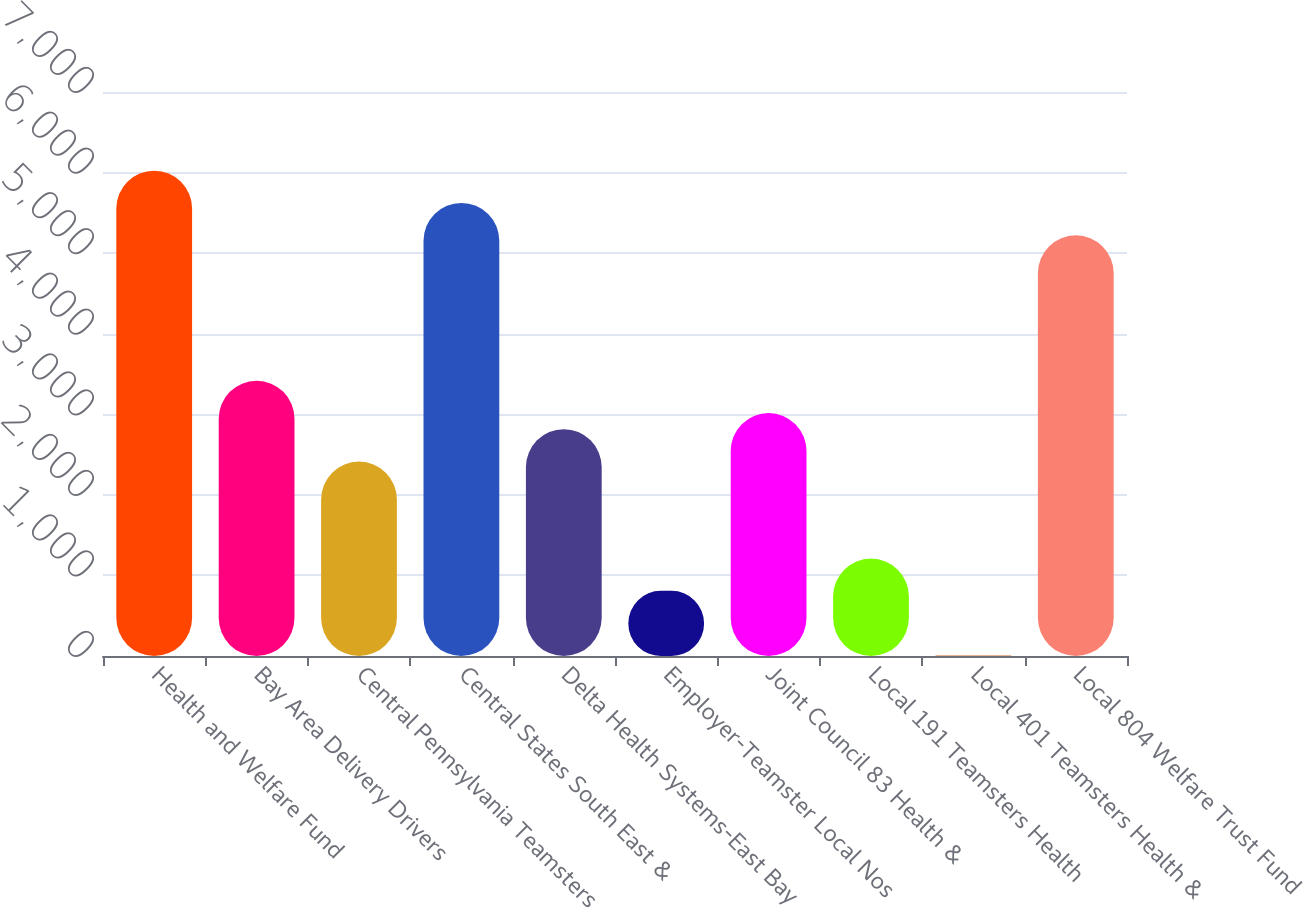Convert chart to OTSL. <chart><loc_0><loc_0><loc_500><loc_500><bar_chart><fcel>Health and Welfare Fund<fcel>Bay Area Delivery Drivers<fcel>Central Pennsylvania Teamsters<fcel>Central States South East &<fcel>Delta Health Systems-East Bay<fcel>Employer-Teamster Local Nos<fcel>Joint Council 83 Health &<fcel>Local 191 Teamsters Health<fcel>Local 401 Teamsters Health &<fcel>Local 804 Welfare Trust Fund<nl><fcel>6024<fcel>3416.2<fcel>2413.2<fcel>5622.8<fcel>2814.4<fcel>808.4<fcel>3015<fcel>1209.6<fcel>6<fcel>5221.6<nl></chart> 